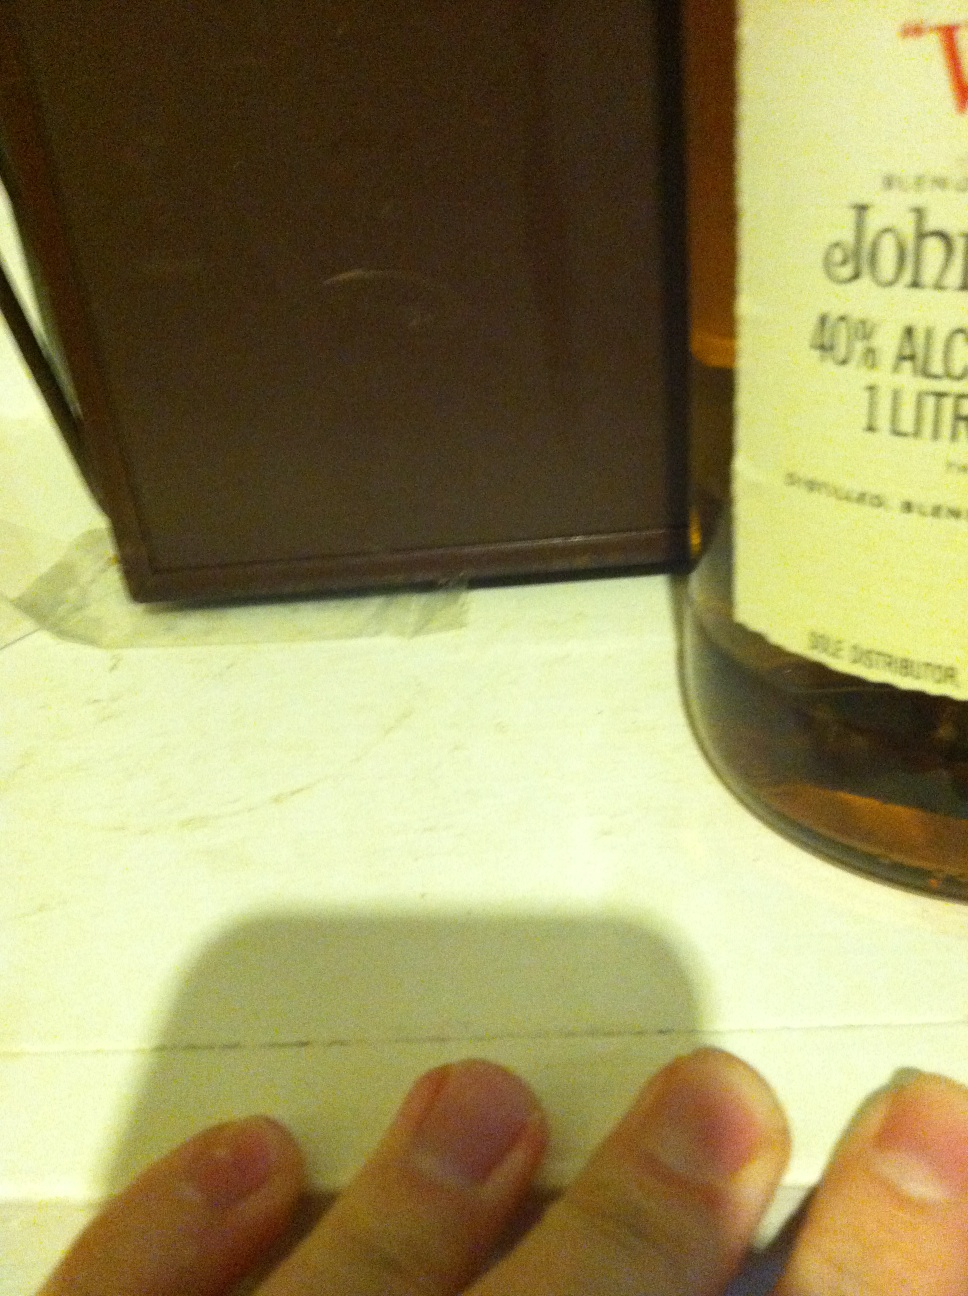What can you tell me about the design of the bottle label? The bottle label has a classic and simple design, featuring a prominent brand name and key information such as alcohol content (40%) and volume (1 liter). The label is primarily in light colors with clear, bold text to ensure readability. This straightforward design focuses on conveying essential details efficiently. 